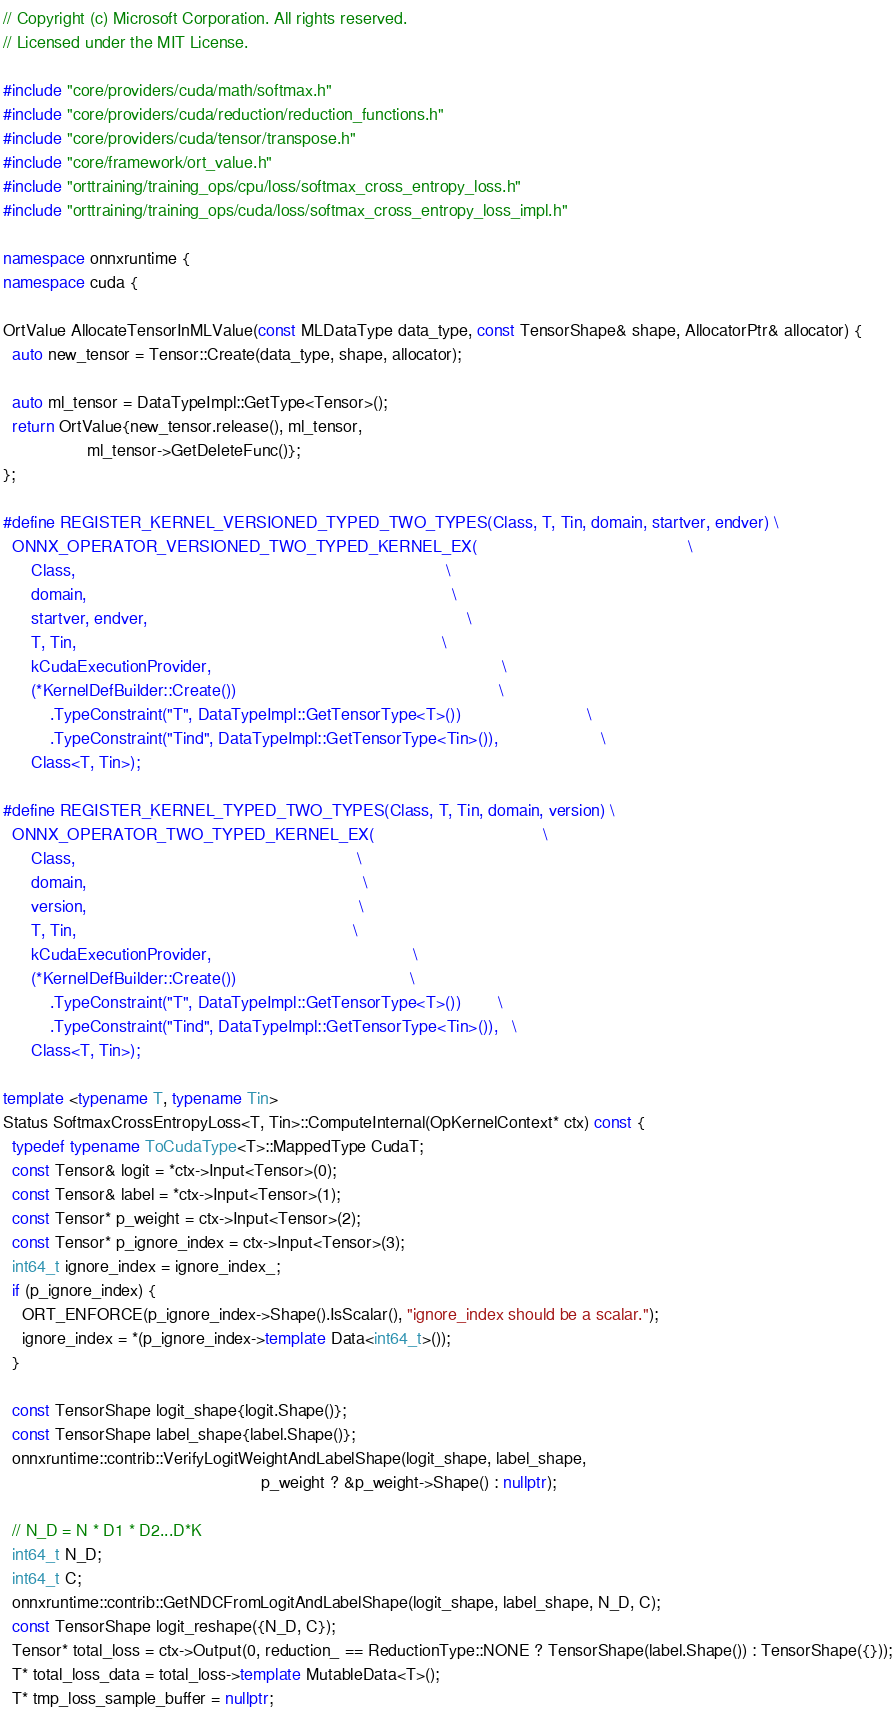Convert code to text. <code><loc_0><loc_0><loc_500><loc_500><_C++_>// Copyright (c) Microsoft Corporation. All rights reserved.
// Licensed under the MIT License.

#include "core/providers/cuda/math/softmax.h"
#include "core/providers/cuda/reduction/reduction_functions.h"
#include "core/providers/cuda/tensor/transpose.h"
#include "core/framework/ort_value.h"
#include "orttraining/training_ops/cpu/loss/softmax_cross_entropy_loss.h"
#include "orttraining/training_ops/cuda/loss/softmax_cross_entropy_loss_impl.h"

namespace onnxruntime {
namespace cuda {

OrtValue AllocateTensorInMLValue(const MLDataType data_type, const TensorShape& shape, AllocatorPtr& allocator) {
  auto new_tensor = Tensor::Create(data_type, shape, allocator);

  auto ml_tensor = DataTypeImpl::GetType<Tensor>();
  return OrtValue{new_tensor.release(), ml_tensor,
                  ml_tensor->GetDeleteFunc()};
};

#define REGISTER_KERNEL_VERSIONED_TYPED_TWO_TYPES(Class, T, Tin, domain, startver, endver) \
  ONNX_OPERATOR_VERSIONED_TWO_TYPED_KERNEL_EX(                                             \
      Class,                                                                               \
      domain,                                                                              \
      startver, endver,                                                                    \
      T, Tin,                                                                              \
      kCudaExecutionProvider,                                                              \
      (*KernelDefBuilder::Create())                                                        \
          .TypeConstraint("T", DataTypeImpl::GetTensorType<T>())                           \
          .TypeConstraint("Tind", DataTypeImpl::GetTensorType<Tin>()),                      \
      Class<T, Tin>);

#define REGISTER_KERNEL_TYPED_TWO_TYPES(Class, T, Tin, domain, version) \
  ONNX_OPERATOR_TWO_TYPED_KERNEL_EX(                                    \
      Class,                                                            \
      domain,                                                           \
      version,                                                          \
      T, Tin,                                                           \
      kCudaExecutionProvider,                                           \
      (*KernelDefBuilder::Create())                                     \
          .TypeConstraint("T", DataTypeImpl::GetTensorType<T>())        \
          .TypeConstraint("Tind", DataTypeImpl::GetTensorType<Tin>()),   \
      Class<T, Tin>);

template <typename T, typename Tin>
Status SoftmaxCrossEntropyLoss<T, Tin>::ComputeInternal(OpKernelContext* ctx) const {
  typedef typename ToCudaType<T>::MappedType CudaT;
  const Tensor& logit = *ctx->Input<Tensor>(0);
  const Tensor& label = *ctx->Input<Tensor>(1);
  const Tensor* p_weight = ctx->Input<Tensor>(2);
  const Tensor* p_ignore_index = ctx->Input<Tensor>(3);
  int64_t ignore_index = ignore_index_;
  if (p_ignore_index) {
    ORT_ENFORCE(p_ignore_index->Shape().IsScalar(), "ignore_index should be a scalar.");
    ignore_index = *(p_ignore_index->template Data<int64_t>());
  }

  const TensorShape logit_shape{logit.Shape()};
  const TensorShape label_shape{label.Shape()};
  onnxruntime::contrib::VerifyLogitWeightAndLabelShape(logit_shape, label_shape,
                                                       p_weight ? &p_weight->Shape() : nullptr);

  // N_D = N * D1 * D2...D*K
  int64_t N_D;
  int64_t C;
  onnxruntime::contrib::GetNDCFromLogitAndLabelShape(logit_shape, label_shape, N_D, C);
  const TensorShape logit_reshape({N_D, C});
  Tensor* total_loss = ctx->Output(0, reduction_ == ReductionType::NONE ? TensorShape(label.Shape()) : TensorShape({}));
  T* total_loss_data = total_loss->template MutableData<T>();
  T* tmp_loss_sample_buffer = nullptr;</code> 